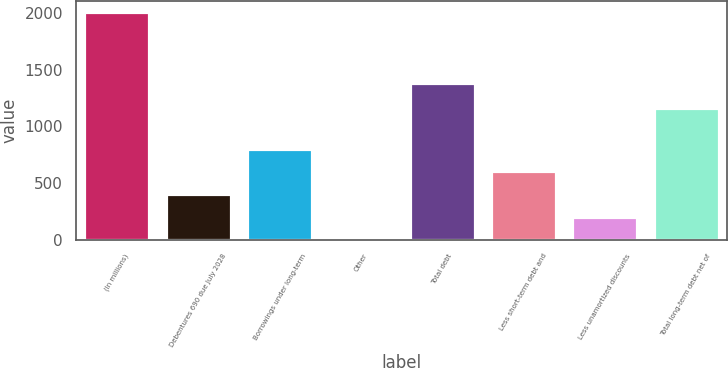<chart> <loc_0><loc_0><loc_500><loc_500><bar_chart><fcel>(In millions)<fcel>Debentures 690 due July 2028<fcel>Borrowings under long-term<fcel>Other<fcel>Total debt<fcel>Less short-term debt and<fcel>Less unamortized discounts<fcel>Total long-term debt net of<nl><fcel>2007<fcel>403.16<fcel>804.12<fcel>2.2<fcel>1384.2<fcel>603.64<fcel>202.68<fcel>1165.2<nl></chart> 